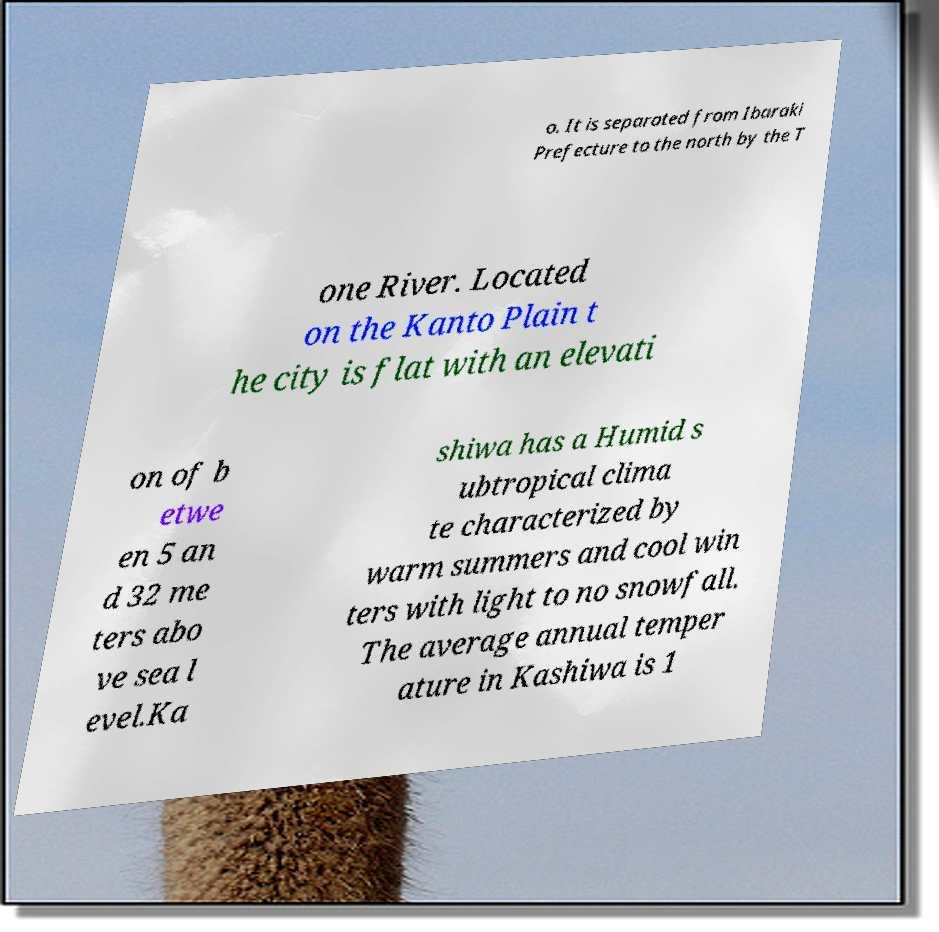Please identify and transcribe the text found in this image. o. It is separated from Ibaraki Prefecture to the north by the T one River. Located on the Kanto Plain t he city is flat with an elevati on of b etwe en 5 an d 32 me ters abo ve sea l evel.Ka shiwa has a Humid s ubtropical clima te characterized by warm summers and cool win ters with light to no snowfall. The average annual temper ature in Kashiwa is 1 